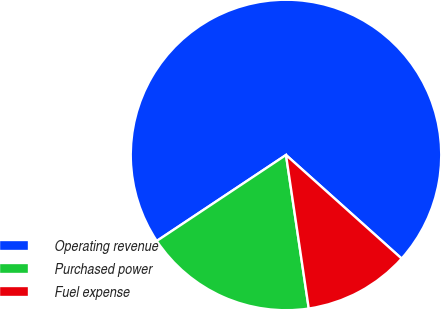Convert chart to OTSL. <chart><loc_0><loc_0><loc_500><loc_500><pie_chart><fcel>Operating revenue<fcel>Purchased power<fcel>Fuel expense<nl><fcel>70.98%<fcel>18.0%<fcel>11.03%<nl></chart> 